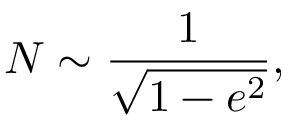<formula> <loc_0><loc_0><loc_500><loc_500>N \sim \frac { 1 } { \sqrt { 1 - e ^ { 2 } } } ,</formula> 